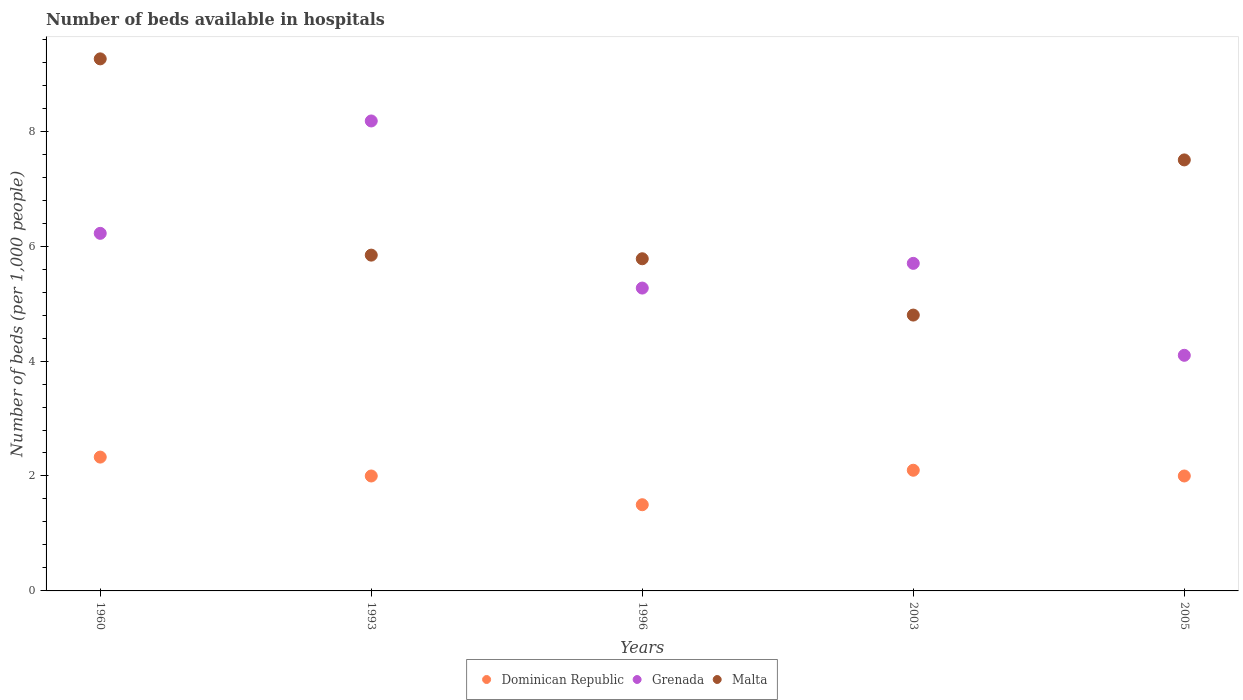Across all years, what is the maximum number of beds in the hospiatls of in Malta?
Give a very brief answer. 9.26. Across all years, what is the minimum number of beds in the hospiatls of in Grenada?
Your answer should be compact. 4.1. In which year was the number of beds in the hospiatls of in Malta maximum?
Ensure brevity in your answer.  1960. In which year was the number of beds in the hospiatls of in Malta minimum?
Keep it short and to the point. 2003. What is the total number of beds in the hospiatls of in Malta in the graph?
Provide a succinct answer. 33.18. What is the difference between the number of beds in the hospiatls of in Malta in 1960 and that in 1993?
Offer a very short reply. 3.42. What is the difference between the number of beds in the hospiatls of in Malta in 2003 and the number of beds in the hospiatls of in Dominican Republic in 1960?
Keep it short and to the point. 2.47. What is the average number of beds in the hospiatls of in Grenada per year?
Keep it short and to the point. 5.89. In the year 1996, what is the difference between the number of beds in the hospiatls of in Malta and number of beds in the hospiatls of in Dominican Republic?
Ensure brevity in your answer.  4.28. What is the ratio of the number of beds in the hospiatls of in Dominican Republic in 1993 to that in 1996?
Your answer should be very brief. 1.33. What is the difference between the highest and the second highest number of beds in the hospiatls of in Grenada?
Ensure brevity in your answer.  1.96. What is the difference between the highest and the lowest number of beds in the hospiatls of in Dominican Republic?
Your answer should be very brief. 0.83. In how many years, is the number of beds in the hospiatls of in Malta greater than the average number of beds in the hospiatls of in Malta taken over all years?
Make the answer very short. 2. Is the sum of the number of beds in the hospiatls of in Grenada in 1996 and 2003 greater than the maximum number of beds in the hospiatls of in Dominican Republic across all years?
Provide a succinct answer. Yes. Is it the case that in every year, the sum of the number of beds in the hospiatls of in Grenada and number of beds in the hospiatls of in Dominican Republic  is greater than the number of beds in the hospiatls of in Malta?
Offer a very short reply. No. Does the number of beds in the hospiatls of in Malta monotonically increase over the years?
Provide a succinct answer. No. How many years are there in the graph?
Your answer should be very brief. 5. What is the difference between two consecutive major ticks on the Y-axis?
Your answer should be compact. 2. Where does the legend appear in the graph?
Make the answer very short. Bottom center. How many legend labels are there?
Ensure brevity in your answer.  3. How are the legend labels stacked?
Ensure brevity in your answer.  Horizontal. What is the title of the graph?
Your answer should be very brief. Number of beds available in hospitals. Does "Cyprus" appear as one of the legend labels in the graph?
Give a very brief answer. No. What is the label or title of the X-axis?
Make the answer very short. Years. What is the label or title of the Y-axis?
Keep it short and to the point. Number of beds (per 1,0 people). What is the Number of beds (per 1,000 people) of Dominican Republic in 1960?
Offer a terse response. 2.33. What is the Number of beds (per 1,000 people) in Grenada in 1960?
Ensure brevity in your answer.  6.22. What is the Number of beds (per 1,000 people) of Malta in 1960?
Provide a succinct answer. 9.26. What is the Number of beds (per 1,000 people) of Dominican Republic in 1993?
Offer a terse response. 2. What is the Number of beds (per 1,000 people) in Grenada in 1993?
Provide a succinct answer. 8.18. What is the Number of beds (per 1,000 people) in Malta in 1993?
Ensure brevity in your answer.  5.84. What is the Number of beds (per 1,000 people) in Dominican Republic in 1996?
Your answer should be very brief. 1.5. What is the Number of beds (per 1,000 people) of Grenada in 1996?
Ensure brevity in your answer.  5.27. What is the Number of beds (per 1,000 people) of Malta in 1996?
Make the answer very short. 5.78. What is the Number of beds (per 1,000 people) in Dominican Republic in 2003?
Give a very brief answer. 2.1. What is the Number of beds (per 1,000 people) in Grenada in 2003?
Your answer should be very brief. 5.7. What is the Number of beds (per 1,000 people) in Malta in 2003?
Make the answer very short. 4.8. What is the Number of beds (per 1,000 people) in Dominican Republic in 2005?
Offer a very short reply. 2. What is the Number of beds (per 1,000 people) of Grenada in 2005?
Your response must be concise. 4.1. What is the Number of beds (per 1,000 people) in Malta in 2005?
Provide a succinct answer. 7.5. Across all years, what is the maximum Number of beds (per 1,000 people) in Dominican Republic?
Ensure brevity in your answer.  2.33. Across all years, what is the maximum Number of beds (per 1,000 people) of Grenada?
Make the answer very short. 8.18. Across all years, what is the maximum Number of beds (per 1,000 people) of Malta?
Offer a terse response. 9.26. Across all years, what is the minimum Number of beds (per 1,000 people) in Grenada?
Your answer should be very brief. 4.1. Across all years, what is the minimum Number of beds (per 1,000 people) in Malta?
Your answer should be compact. 4.8. What is the total Number of beds (per 1,000 people) of Dominican Republic in the graph?
Offer a very short reply. 9.93. What is the total Number of beds (per 1,000 people) of Grenada in the graph?
Provide a succinct answer. 29.47. What is the total Number of beds (per 1,000 people) in Malta in the graph?
Your answer should be compact. 33.18. What is the difference between the Number of beds (per 1,000 people) of Dominican Republic in 1960 and that in 1993?
Make the answer very short. 0.33. What is the difference between the Number of beds (per 1,000 people) of Grenada in 1960 and that in 1993?
Make the answer very short. -1.96. What is the difference between the Number of beds (per 1,000 people) in Malta in 1960 and that in 1993?
Keep it short and to the point. 3.42. What is the difference between the Number of beds (per 1,000 people) of Dominican Republic in 1960 and that in 1996?
Offer a terse response. 0.83. What is the difference between the Number of beds (per 1,000 people) of Grenada in 1960 and that in 1996?
Offer a terse response. 0.95. What is the difference between the Number of beds (per 1,000 people) in Malta in 1960 and that in 1996?
Provide a succinct answer. 3.48. What is the difference between the Number of beds (per 1,000 people) in Dominican Republic in 1960 and that in 2003?
Keep it short and to the point. 0.23. What is the difference between the Number of beds (per 1,000 people) of Grenada in 1960 and that in 2003?
Keep it short and to the point. 0.52. What is the difference between the Number of beds (per 1,000 people) in Malta in 1960 and that in 2003?
Your answer should be very brief. 4.46. What is the difference between the Number of beds (per 1,000 people) in Dominican Republic in 1960 and that in 2005?
Your answer should be compact. 0.33. What is the difference between the Number of beds (per 1,000 people) in Grenada in 1960 and that in 2005?
Keep it short and to the point. 2.12. What is the difference between the Number of beds (per 1,000 people) in Malta in 1960 and that in 2005?
Provide a succinct answer. 1.76. What is the difference between the Number of beds (per 1,000 people) of Dominican Republic in 1993 and that in 1996?
Your answer should be compact. 0.5. What is the difference between the Number of beds (per 1,000 people) in Grenada in 1993 and that in 1996?
Keep it short and to the point. 2.91. What is the difference between the Number of beds (per 1,000 people) of Malta in 1993 and that in 1996?
Give a very brief answer. 0.06. What is the difference between the Number of beds (per 1,000 people) of Dominican Republic in 1993 and that in 2003?
Keep it short and to the point. -0.1. What is the difference between the Number of beds (per 1,000 people) in Grenada in 1993 and that in 2003?
Provide a short and direct response. 2.48. What is the difference between the Number of beds (per 1,000 people) in Malta in 1993 and that in 2003?
Your response must be concise. 1.04. What is the difference between the Number of beds (per 1,000 people) of Grenada in 1993 and that in 2005?
Keep it short and to the point. 4.08. What is the difference between the Number of beds (per 1,000 people) in Malta in 1993 and that in 2005?
Give a very brief answer. -1.66. What is the difference between the Number of beds (per 1,000 people) in Grenada in 1996 and that in 2003?
Ensure brevity in your answer.  -0.43. What is the difference between the Number of beds (per 1,000 people) of Grenada in 1996 and that in 2005?
Give a very brief answer. 1.17. What is the difference between the Number of beds (per 1,000 people) in Malta in 1996 and that in 2005?
Provide a short and direct response. -1.72. What is the difference between the Number of beds (per 1,000 people) of Dominican Republic in 2003 and that in 2005?
Your answer should be compact. 0.1. What is the difference between the Number of beds (per 1,000 people) of Dominican Republic in 1960 and the Number of beds (per 1,000 people) of Grenada in 1993?
Make the answer very short. -5.85. What is the difference between the Number of beds (per 1,000 people) in Dominican Republic in 1960 and the Number of beds (per 1,000 people) in Malta in 1993?
Make the answer very short. -3.51. What is the difference between the Number of beds (per 1,000 people) in Grenada in 1960 and the Number of beds (per 1,000 people) in Malta in 1993?
Make the answer very short. 0.38. What is the difference between the Number of beds (per 1,000 people) of Dominican Republic in 1960 and the Number of beds (per 1,000 people) of Grenada in 1996?
Your response must be concise. -2.94. What is the difference between the Number of beds (per 1,000 people) in Dominican Republic in 1960 and the Number of beds (per 1,000 people) in Malta in 1996?
Give a very brief answer. -3.45. What is the difference between the Number of beds (per 1,000 people) in Grenada in 1960 and the Number of beds (per 1,000 people) in Malta in 1996?
Give a very brief answer. 0.44. What is the difference between the Number of beds (per 1,000 people) of Dominican Republic in 1960 and the Number of beds (per 1,000 people) of Grenada in 2003?
Your response must be concise. -3.37. What is the difference between the Number of beds (per 1,000 people) of Dominican Republic in 1960 and the Number of beds (per 1,000 people) of Malta in 2003?
Offer a terse response. -2.47. What is the difference between the Number of beds (per 1,000 people) of Grenada in 1960 and the Number of beds (per 1,000 people) of Malta in 2003?
Give a very brief answer. 1.42. What is the difference between the Number of beds (per 1,000 people) in Dominican Republic in 1960 and the Number of beds (per 1,000 people) in Grenada in 2005?
Provide a short and direct response. -1.77. What is the difference between the Number of beds (per 1,000 people) of Dominican Republic in 1960 and the Number of beds (per 1,000 people) of Malta in 2005?
Offer a terse response. -5.17. What is the difference between the Number of beds (per 1,000 people) in Grenada in 1960 and the Number of beds (per 1,000 people) in Malta in 2005?
Offer a terse response. -1.28. What is the difference between the Number of beds (per 1,000 people) in Dominican Republic in 1993 and the Number of beds (per 1,000 people) in Grenada in 1996?
Ensure brevity in your answer.  -3.27. What is the difference between the Number of beds (per 1,000 people) in Dominican Republic in 1993 and the Number of beds (per 1,000 people) in Malta in 1996?
Offer a very short reply. -3.78. What is the difference between the Number of beds (per 1,000 people) of Grenada in 1993 and the Number of beds (per 1,000 people) of Malta in 1996?
Your answer should be compact. 2.4. What is the difference between the Number of beds (per 1,000 people) in Dominican Republic in 1993 and the Number of beds (per 1,000 people) in Malta in 2003?
Offer a very short reply. -2.8. What is the difference between the Number of beds (per 1,000 people) of Grenada in 1993 and the Number of beds (per 1,000 people) of Malta in 2003?
Your response must be concise. 3.38. What is the difference between the Number of beds (per 1,000 people) of Grenada in 1993 and the Number of beds (per 1,000 people) of Malta in 2005?
Your answer should be compact. 0.68. What is the difference between the Number of beds (per 1,000 people) of Dominican Republic in 1996 and the Number of beds (per 1,000 people) of Malta in 2003?
Provide a short and direct response. -3.3. What is the difference between the Number of beds (per 1,000 people) of Grenada in 1996 and the Number of beds (per 1,000 people) of Malta in 2003?
Your answer should be compact. 0.47. What is the difference between the Number of beds (per 1,000 people) of Dominican Republic in 1996 and the Number of beds (per 1,000 people) of Malta in 2005?
Ensure brevity in your answer.  -6. What is the difference between the Number of beds (per 1,000 people) in Grenada in 1996 and the Number of beds (per 1,000 people) in Malta in 2005?
Ensure brevity in your answer.  -2.23. What is the difference between the Number of beds (per 1,000 people) of Dominican Republic in 2003 and the Number of beds (per 1,000 people) of Grenada in 2005?
Provide a succinct answer. -2. What is the average Number of beds (per 1,000 people) in Dominican Republic per year?
Offer a terse response. 1.99. What is the average Number of beds (per 1,000 people) in Grenada per year?
Keep it short and to the point. 5.89. What is the average Number of beds (per 1,000 people) in Malta per year?
Give a very brief answer. 6.64. In the year 1960, what is the difference between the Number of beds (per 1,000 people) in Dominican Republic and Number of beds (per 1,000 people) in Grenada?
Keep it short and to the point. -3.89. In the year 1960, what is the difference between the Number of beds (per 1,000 people) in Dominican Republic and Number of beds (per 1,000 people) in Malta?
Offer a terse response. -6.93. In the year 1960, what is the difference between the Number of beds (per 1,000 people) of Grenada and Number of beds (per 1,000 people) of Malta?
Give a very brief answer. -3.04. In the year 1993, what is the difference between the Number of beds (per 1,000 people) of Dominican Republic and Number of beds (per 1,000 people) of Grenada?
Your response must be concise. -6.18. In the year 1993, what is the difference between the Number of beds (per 1,000 people) of Dominican Republic and Number of beds (per 1,000 people) of Malta?
Give a very brief answer. -3.84. In the year 1993, what is the difference between the Number of beds (per 1,000 people) of Grenada and Number of beds (per 1,000 people) of Malta?
Your answer should be compact. 2.33. In the year 1996, what is the difference between the Number of beds (per 1,000 people) of Dominican Republic and Number of beds (per 1,000 people) of Grenada?
Make the answer very short. -3.77. In the year 1996, what is the difference between the Number of beds (per 1,000 people) in Dominican Republic and Number of beds (per 1,000 people) in Malta?
Keep it short and to the point. -4.28. In the year 1996, what is the difference between the Number of beds (per 1,000 people) in Grenada and Number of beds (per 1,000 people) in Malta?
Keep it short and to the point. -0.51. In the year 2003, what is the difference between the Number of beds (per 1,000 people) of Grenada and Number of beds (per 1,000 people) of Malta?
Keep it short and to the point. 0.9. In the year 2005, what is the difference between the Number of beds (per 1,000 people) in Grenada and Number of beds (per 1,000 people) in Malta?
Your answer should be compact. -3.4. What is the ratio of the Number of beds (per 1,000 people) of Dominican Republic in 1960 to that in 1993?
Offer a terse response. 1.16. What is the ratio of the Number of beds (per 1,000 people) of Grenada in 1960 to that in 1993?
Make the answer very short. 0.76. What is the ratio of the Number of beds (per 1,000 people) of Malta in 1960 to that in 1993?
Offer a terse response. 1.58. What is the ratio of the Number of beds (per 1,000 people) in Dominican Republic in 1960 to that in 1996?
Ensure brevity in your answer.  1.55. What is the ratio of the Number of beds (per 1,000 people) in Grenada in 1960 to that in 1996?
Make the answer very short. 1.18. What is the ratio of the Number of beds (per 1,000 people) of Malta in 1960 to that in 1996?
Provide a short and direct response. 1.6. What is the ratio of the Number of beds (per 1,000 people) in Dominican Republic in 1960 to that in 2003?
Offer a very short reply. 1.11. What is the ratio of the Number of beds (per 1,000 people) of Grenada in 1960 to that in 2003?
Provide a succinct answer. 1.09. What is the ratio of the Number of beds (per 1,000 people) in Malta in 1960 to that in 2003?
Your response must be concise. 1.93. What is the ratio of the Number of beds (per 1,000 people) in Dominican Republic in 1960 to that in 2005?
Make the answer very short. 1.16. What is the ratio of the Number of beds (per 1,000 people) in Grenada in 1960 to that in 2005?
Your answer should be very brief. 1.52. What is the ratio of the Number of beds (per 1,000 people) of Malta in 1960 to that in 2005?
Ensure brevity in your answer.  1.23. What is the ratio of the Number of beds (per 1,000 people) in Grenada in 1993 to that in 1996?
Offer a terse response. 1.55. What is the ratio of the Number of beds (per 1,000 people) in Malta in 1993 to that in 1996?
Keep it short and to the point. 1.01. What is the ratio of the Number of beds (per 1,000 people) of Grenada in 1993 to that in 2003?
Ensure brevity in your answer.  1.43. What is the ratio of the Number of beds (per 1,000 people) of Malta in 1993 to that in 2003?
Offer a terse response. 1.22. What is the ratio of the Number of beds (per 1,000 people) in Grenada in 1993 to that in 2005?
Your answer should be compact. 1.99. What is the ratio of the Number of beds (per 1,000 people) in Malta in 1993 to that in 2005?
Your answer should be compact. 0.78. What is the ratio of the Number of beds (per 1,000 people) in Grenada in 1996 to that in 2003?
Make the answer very short. 0.92. What is the ratio of the Number of beds (per 1,000 people) in Malta in 1996 to that in 2003?
Offer a terse response. 1.2. What is the ratio of the Number of beds (per 1,000 people) of Grenada in 1996 to that in 2005?
Provide a short and direct response. 1.29. What is the ratio of the Number of beds (per 1,000 people) of Malta in 1996 to that in 2005?
Make the answer very short. 0.77. What is the ratio of the Number of beds (per 1,000 people) of Dominican Republic in 2003 to that in 2005?
Ensure brevity in your answer.  1.05. What is the ratio of the Number of beds (per 1,000 people) in Grenada in 2003 to that in 2005?
Provide a short and direct response. 1.39. What is the ratio of the Number of beds (per 1,000 people) in Malta in 2003 to that in 2005?
Keep it short and to the point. 0.64. What is the difference between the highest and the second highest Number of beds (per 1,000 people) of Dominican Republic?
Your response must be concise. 0.23. What is the difference between the highest and the second highest Number of beds (per 1,000 people) of Grenada?
Offer a very short reply. 1.96. What is the difference between the highest and the second highest Number of beds (per 1,000 people) of Malta?
Make the answer very short. 1.76. What is the difference between the highest and the lowest Number of beds (per 1,000 people) in Dominican Republic?
Keep it short and to the point. 0.83. What is the difference between the highest and the lowest Number of beds (per 1,000 people) of Grenada?
Give a very brief answer. 4.08. What is the difference between the highest and the lowest Number of beds (per 1,000 people) of Malta?
Offer a terse response. 4.46. 